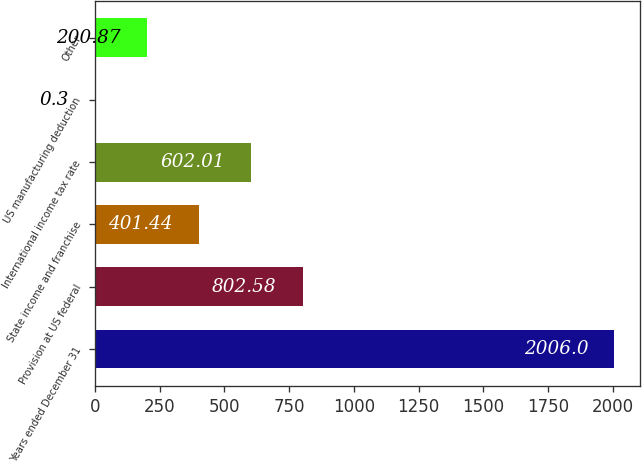Convert chart to OTSL. <chart><loc_0><loc_0><loc_500><loc_500><bar_chart><fcel>Years ended December 31<fcel>Provision at US federal<fcel>State income and franchise<fcel>International income tax rate<fcel>US manufacturing deduction<fcel>Other<nl><fcel>2006<fcel>802.58<fcel>401.44<fcel>602.01<fcel>0.3<fcel>200.87<nl></chart> 